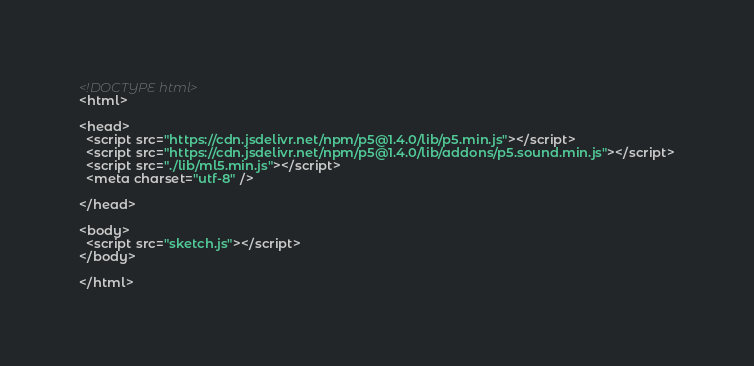<code> <loc_0><loc_0><loc_500><loc_500><_HTML_><!DOCTYPE html>
<html>

<head>
  <script src="https://cdn.jsdelivr.net/npm/p5@1.4.0/lib/p5.min.js"></script>
  <script src="https://cdn.jsdelivr.net/npm/p5@1.4.0/lib/addons/p5.sound.min.js"></script>
  <script src="./lib/ml5.min.js"></script>
  <meta charset="utf-8" />

</head>

<body>
  <script src="sketch.js"></script>
</body>

</html></code> 